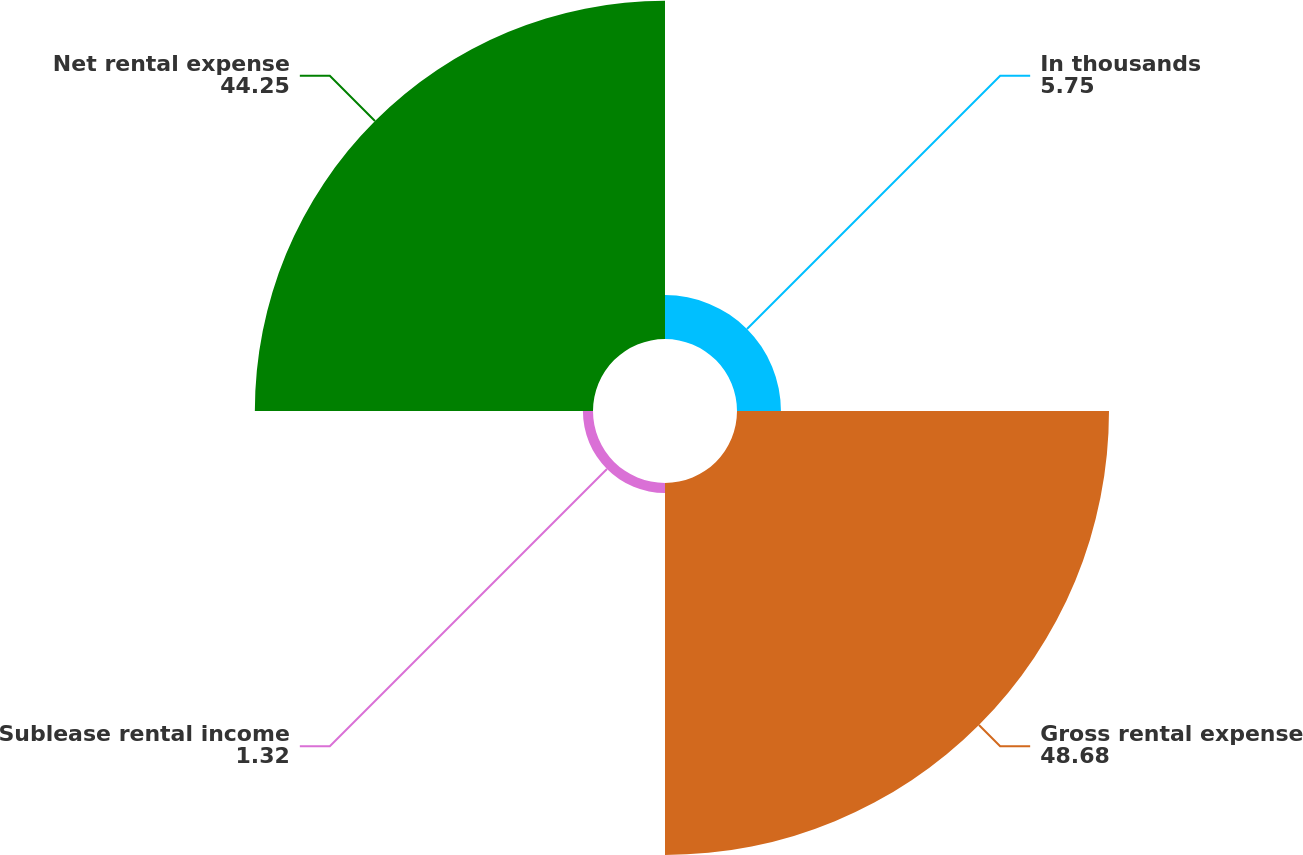<chart> <loc_0><loc_0><loc_500><loc_500><pie_chart><fcel>In thousands<fcel>Gross rental expense<fcel>Sublease rental income<fcel>Net rental expense<nl><fcel>5.75%<fcel>48.68%<fcel>1.32%<fcel>44.25%<nl></chart> 